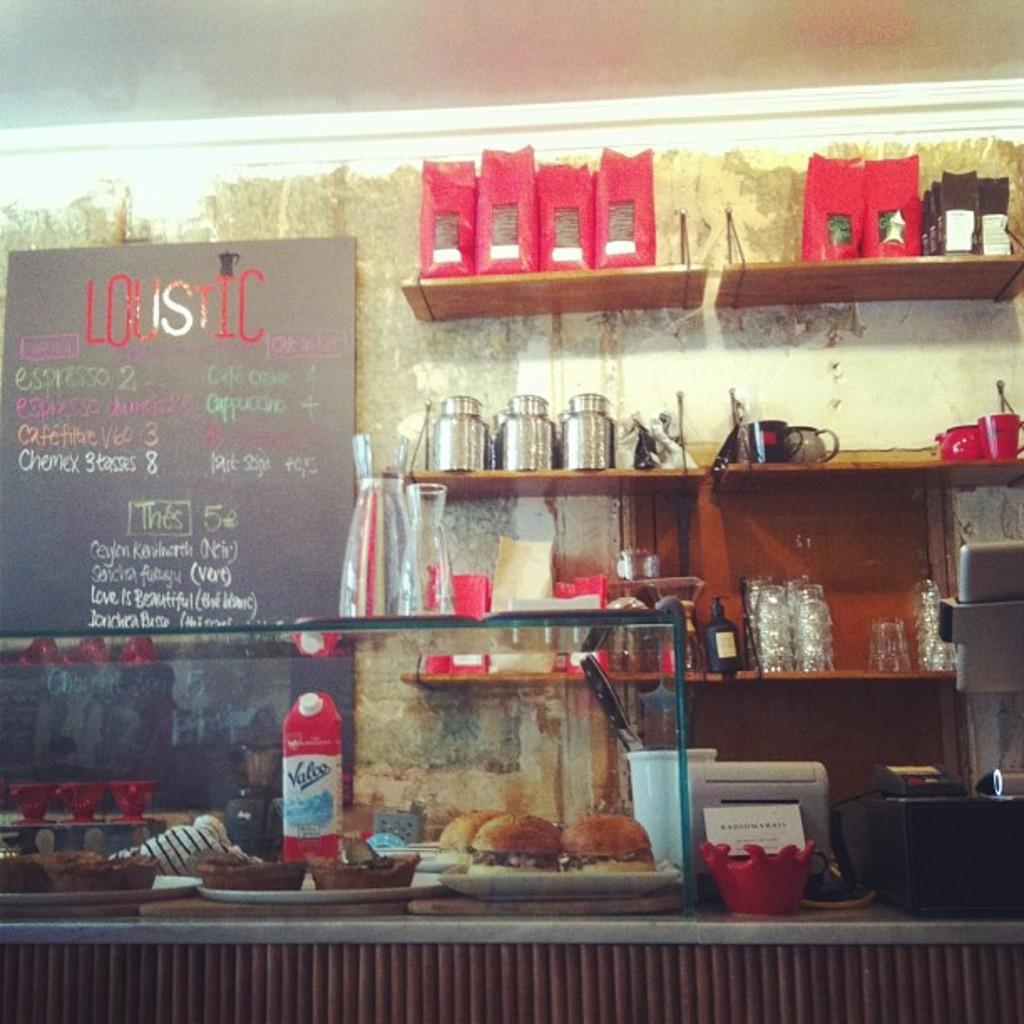What is on the menu today?
Give a very brief answer. Espresso. 